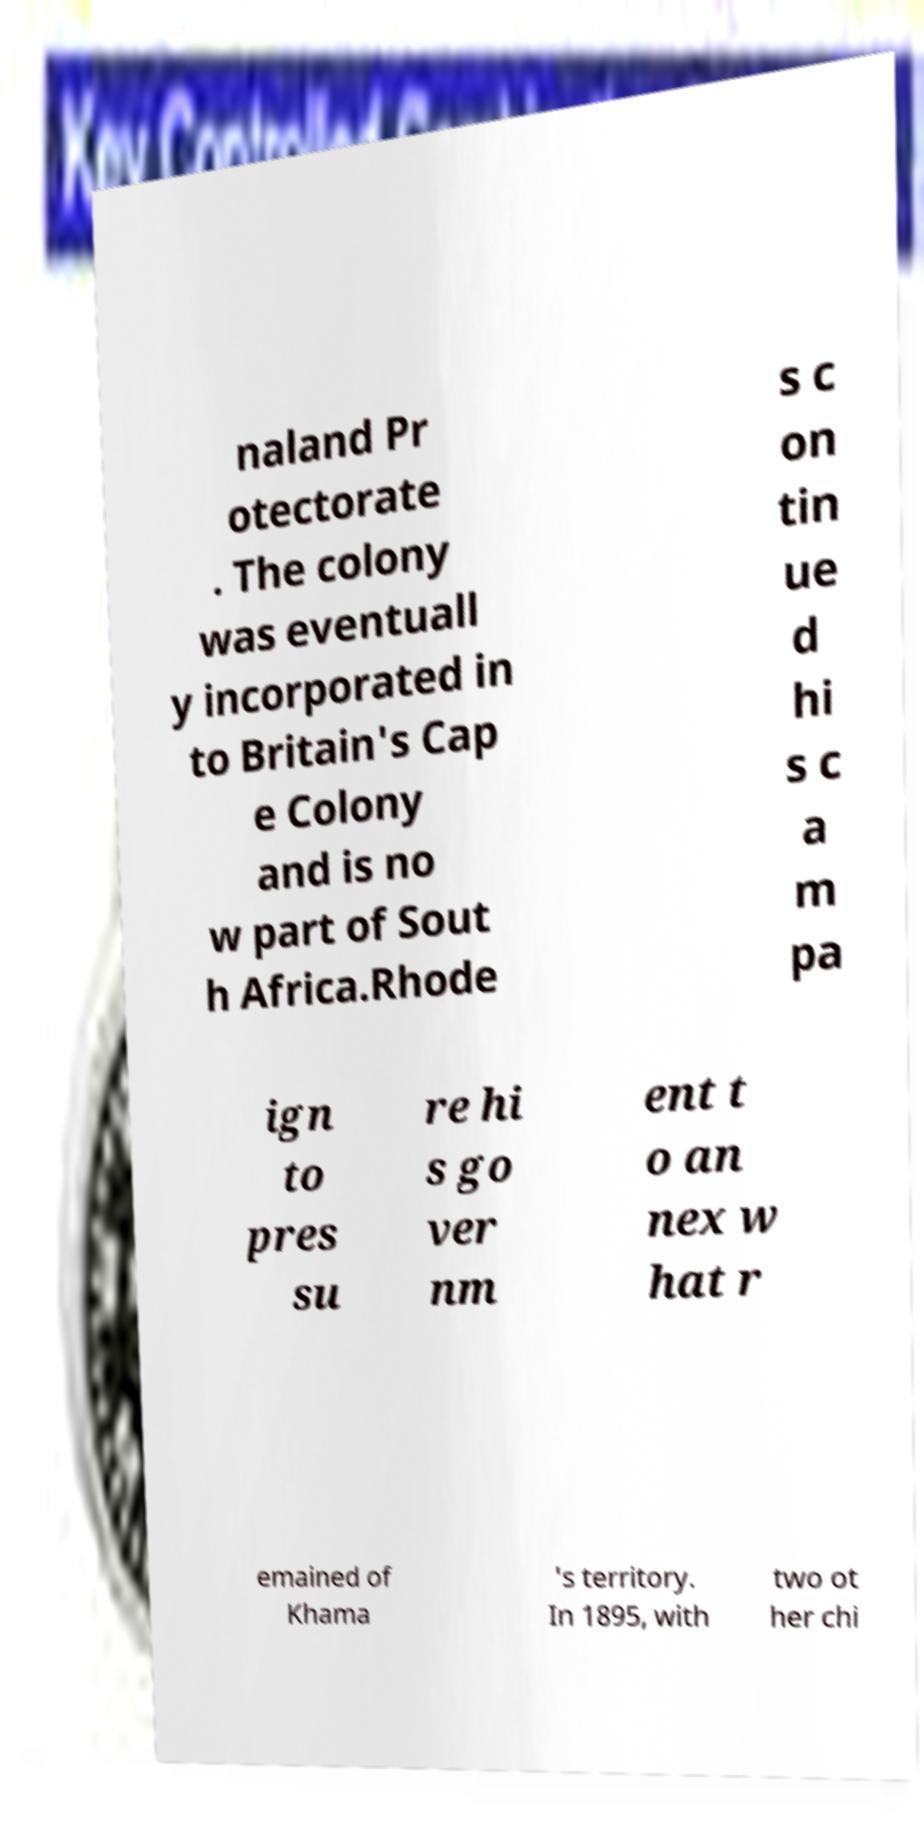Please read and relay the text visible in this image. What does it say? naland Pr otectorate . The colony was eventuall y incorporated in to Britain's Cap e Colony and is no w part of Sout h Africa.Rhode s c on tin ue d hi s c a m pa ign to pres su re hi s go ver nm ent t o an nex w hat r emained of Khama 's territory. In 1895, with two ot her chi 